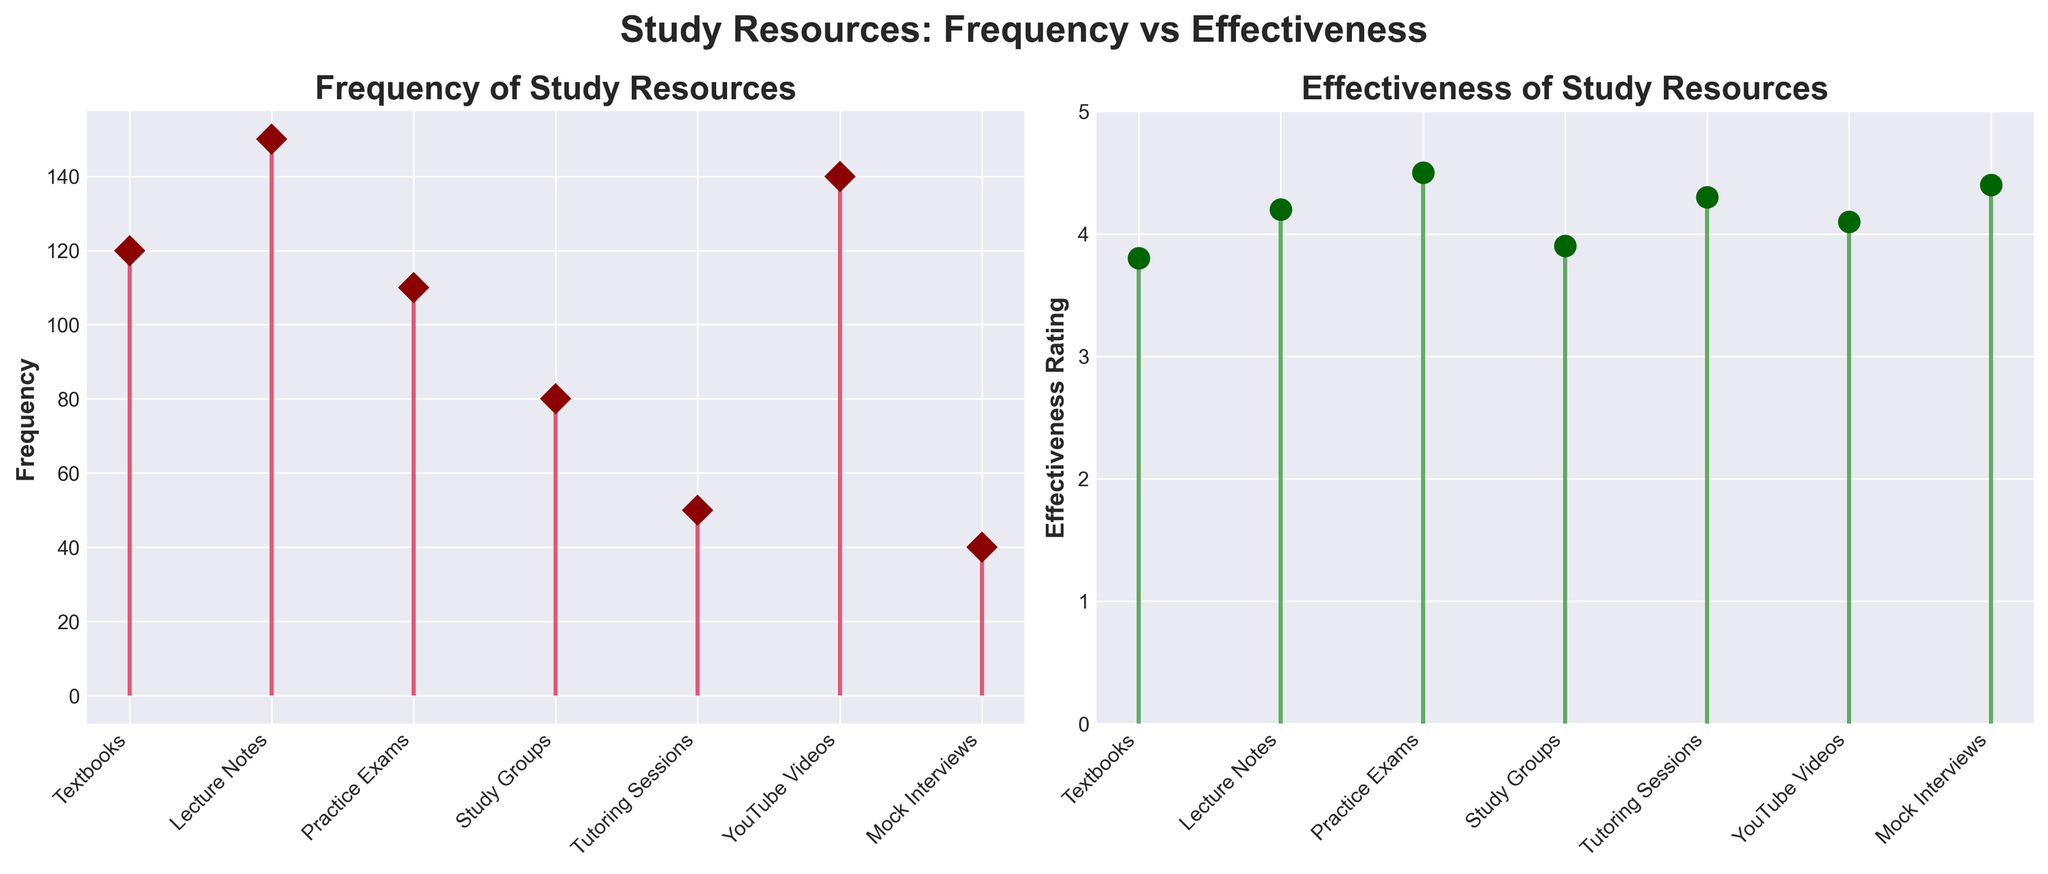What is the title of the figure? The title of the figure summarizes the overall content and objective of the visual representation. It is located at the top center of the figure.
Answer: Study Resources: Frequency vs Effectiveness How many types of study resources are analyzed in the figure? The number of types of study resources can be counted by observing the number of unique labels along the x-axis in either subplot.
Answer: 7 Which study resource has the highest frequency? To find the study resource with the highest frequency, compare the lengths of the stems in the first subplot (Frequency). The longest stem indicates the highest frequency.
Answer: Lecture Notes What is the effectiveness rating for YouTube Videos? Look at the stem plot in the second subplot (Effectiveness) at the position corresponding to "YouTube Videos" on the x-axis.
Answer: 4.1 What is the total frequency of all the study resources combined? Add the frequency values of all study resources: 120 (Textbooks) + 150 (Lecture Notes) + 110 (Practice Exams) + 80 (Study Groups) + 50 (Tutoring Sessions) + 140 (YouTube Videos) + 40 (Mock Interviews) = 690.
Answer: 690 Which study resources have an effectiveness rating above 4.0? Identify the study resources in the second subplot (Effectiveness) with stems extending above the 4.0 mark on the y-axis.
Answer: Lecture Notes, Practice Exams, Tutoring Sessions, YouTube Videos, Mock Interviews Which study resource has both low frequency and high effectiveness? Find the study resource with a relatively short stem in the first subplot (low frequency) and a relatively long stem in the second subplot (high effectiveness).
Answer: Mock Interviews What is the difference in effectiveness rating between Lecture Notes and Study Groups? Subtract the effectiveness rating of Study Groups from that of Lecture Notes: 4.2 (Lecture Notes) - 3.9 (Study Groups) = 0.3.
Answer: 0.3 How does the effectiveness rating of Practice Exams compare to Tutoring Sessions? Compare the lengths of the stems for Practice Exams and Tutoring Sessions in the second subplot. Practice Exams has a length slightly less than Tutoring Sessions.
Answer: Tutoring Sessions is slightly more effective What is the average effectiveness rating of all study resources? Summing all effectiveness ratings: 3.8 (Textbooks) + 4.2 (Lecture Notes) + 4.5 (Practice Exams) + 3.9 (Study Groups) + 4.3 (Tutoring Sessions) + 4.1 (YouTube Videos) + 4.4 (Mock Interviews) = 29.2. Dividing by the number of resources (7): 29.2/7 ≈ 4.17.
Answer: 4.17 